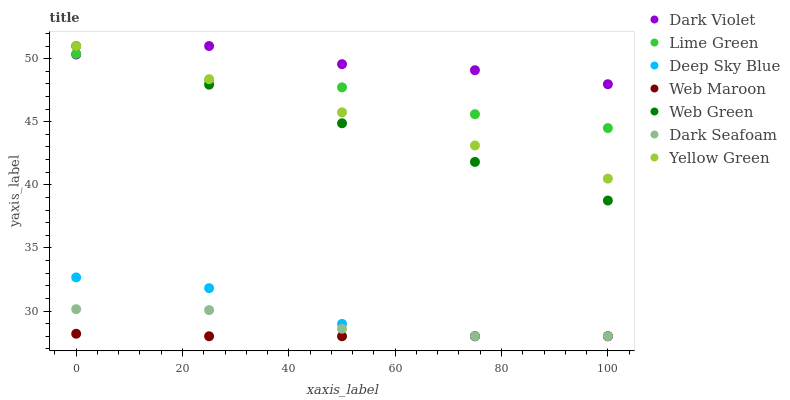Does Web Maroon have the minimum area under the curve?
Answer yes or no. Yes. Does Dark Violet have the maximum area under the curve?
Answer yes or no. Yes. Does Web Green have the minimum area under the curve?
Answer yes or no. No. Does Web Green have the maximum area under the curve?
Answer yes or no. No. Is Web Green the smoothest?
Answer yes or no. Yes. Is Deep Sky Blue the roughest?
Answer yes or no. Yes. Is Web Maroon the smoothest?
Answer yes or no. No. Is Web Maroon the roughest?
Answer yes or no. No. Does Web Maroon have the lowest value?
Answer yes or no. Yes. Does Web Green have the lowest value?
Answer yes or no. No. Does Dark Violet have the highest value?
Answer yes or no. Yes. Does Web Maroon have the highest value?
Answer yes or no. No. Is Deep Sky Blue less than Web Green?
Answer yes or no. Yes. Is Dark Violet greater than Deep Sky Blue?
Answer yes or no. Yes. Does Lime Green intersect Dark Violet?
Answer yes or no. Yes. Is Lime Green less than Dark Violet?
Answer yes or no. No. Is Lime Green greater than Dark Violet?
Answer yes or no. No. Does Deep Sky Blue intersect Web Green?
Answer yes or no. No. 